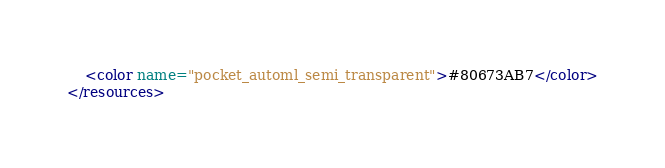<code> <loc_0><loc_0><loc_500><loc_500><_XML_>    <color name="pocket_automl_semi_transparent">#80673AB7</color>
</resources>
</code> 